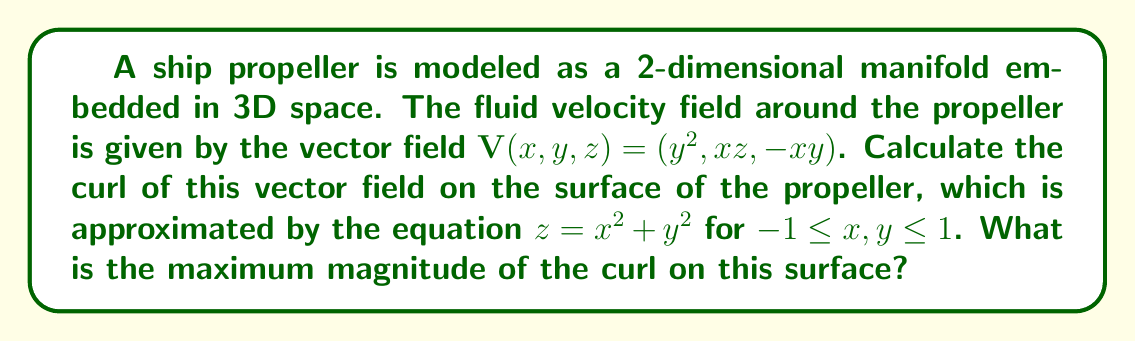Solve this math problem. To solve this problem, we'll follow these steps:

1) First, we need to calculate the curl of the vector field $\mathbf{V}(x,y,z)$. The curl in 3D is given by:

   $$\text{curl}(\mathbf{V}) = \nabla \times \mathbf{V} = \left(\frac{\partial V_z}{\partial y} - \frac{\partial V_y}{\partial z}, \frac{\partial V_x}{\partial z} - \frac{\partial V_z}{\partial x}, \frac{\partial V_y}{\partial x} - \frac{\partial V_x}{\partial y}\right)$$

2) Let's calculate each component:
   
   $\frac{\partial V_z}{\partial y} - \frac{\partial V_y}{\partial z} = -x - 0 = -x$
   
   $\frac{\partial V_x}{\partial z} - \frac{\partial V_z}{\partial x} = 0 - (-y) = y$
   
   $\frac{\partial V_y}{\partial x} - \frac{\partial V_x}{\partial y} = z - 2y = z - 2y$

3) Therefore, the curl is:

   $$\text{curl}(\mathbf{V}) = (-x, y, z-2y)$$

4) Now, we need to consider this curl on the surface $z = x^2 + y^2$. Substituting this into our curl:

   $$\text{curl}(\mathbf{V}) = (-x, y, x^2+y^2-2y)$$

5) The magnitude of this curl is:

   $$\|\text{curl}(\mathbf{V})\| = \sqrt{x^2 + y^2 + (x^2+y^2-2y)^2}$$

6) To find the maximum magnitude, we need to maximize this function over the domain $-1 \leq x,y \leq 1$. This is a complex optimization problem, but we can observe that the maximum will occur at the edges of the domain where $x$ and $y$ take on their extreme values.

7) Let's consider the corners of our square domain:
   
   At (1,1): $\sqrt{1^2 + 1^2 + (1^2+1^2-2)^2} = \sqrt{2}$
   
   At (1,-1): $\sqrt{1^2 + (-1)^2 + (1^2+(-1)^2+2)^2} = \sqrt{17}$
   
   At (-1,1): $\sqrt{(-1)^2 + 1^2 + ((-1)^2+1^2-2)^2} = \sqrt{2}$
   
   At (-1,-1): $\sqrt{(-1)^2 + (-1)^2 + ((-1)^2+(-1)^2+2)^2} = \sqrt{17}$

8) The maximum value occurs at (1,-1) and (-1,-1), with a magnitude of $\sqrt{17}$.
Answer: The maximum magnitude of the curl on the given surface is $\sqrt{17}$. 